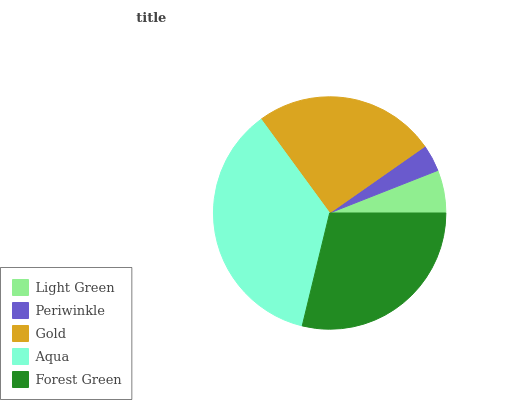Is Periwinkle the minimum?
Answer yes or no. Yes. Is Aqua the maximum?
Answer yes or no. Yes. Is Gold the minimum?
Answer yes or no. No. Is Gold the maximum?
Answer yes or no. No. Is Gold greater than Periwinkle?
Answer yes or no. Yes. Is Periwinkle less than Gold?
Answer yes or no. Yes. Is Periwinkle greater than Gold?
Answer yes or no. No. Is Gold less than Periwinkle?
Answer yes or no. No. Is Gold the high median?
Answer yes or no. Yes. Is Gold the low median?
Answer yes or no. Yes. Is Aqua the high median?
Answer yes or no. No. Is Light Green the low median?
Answer yes or no. No. 